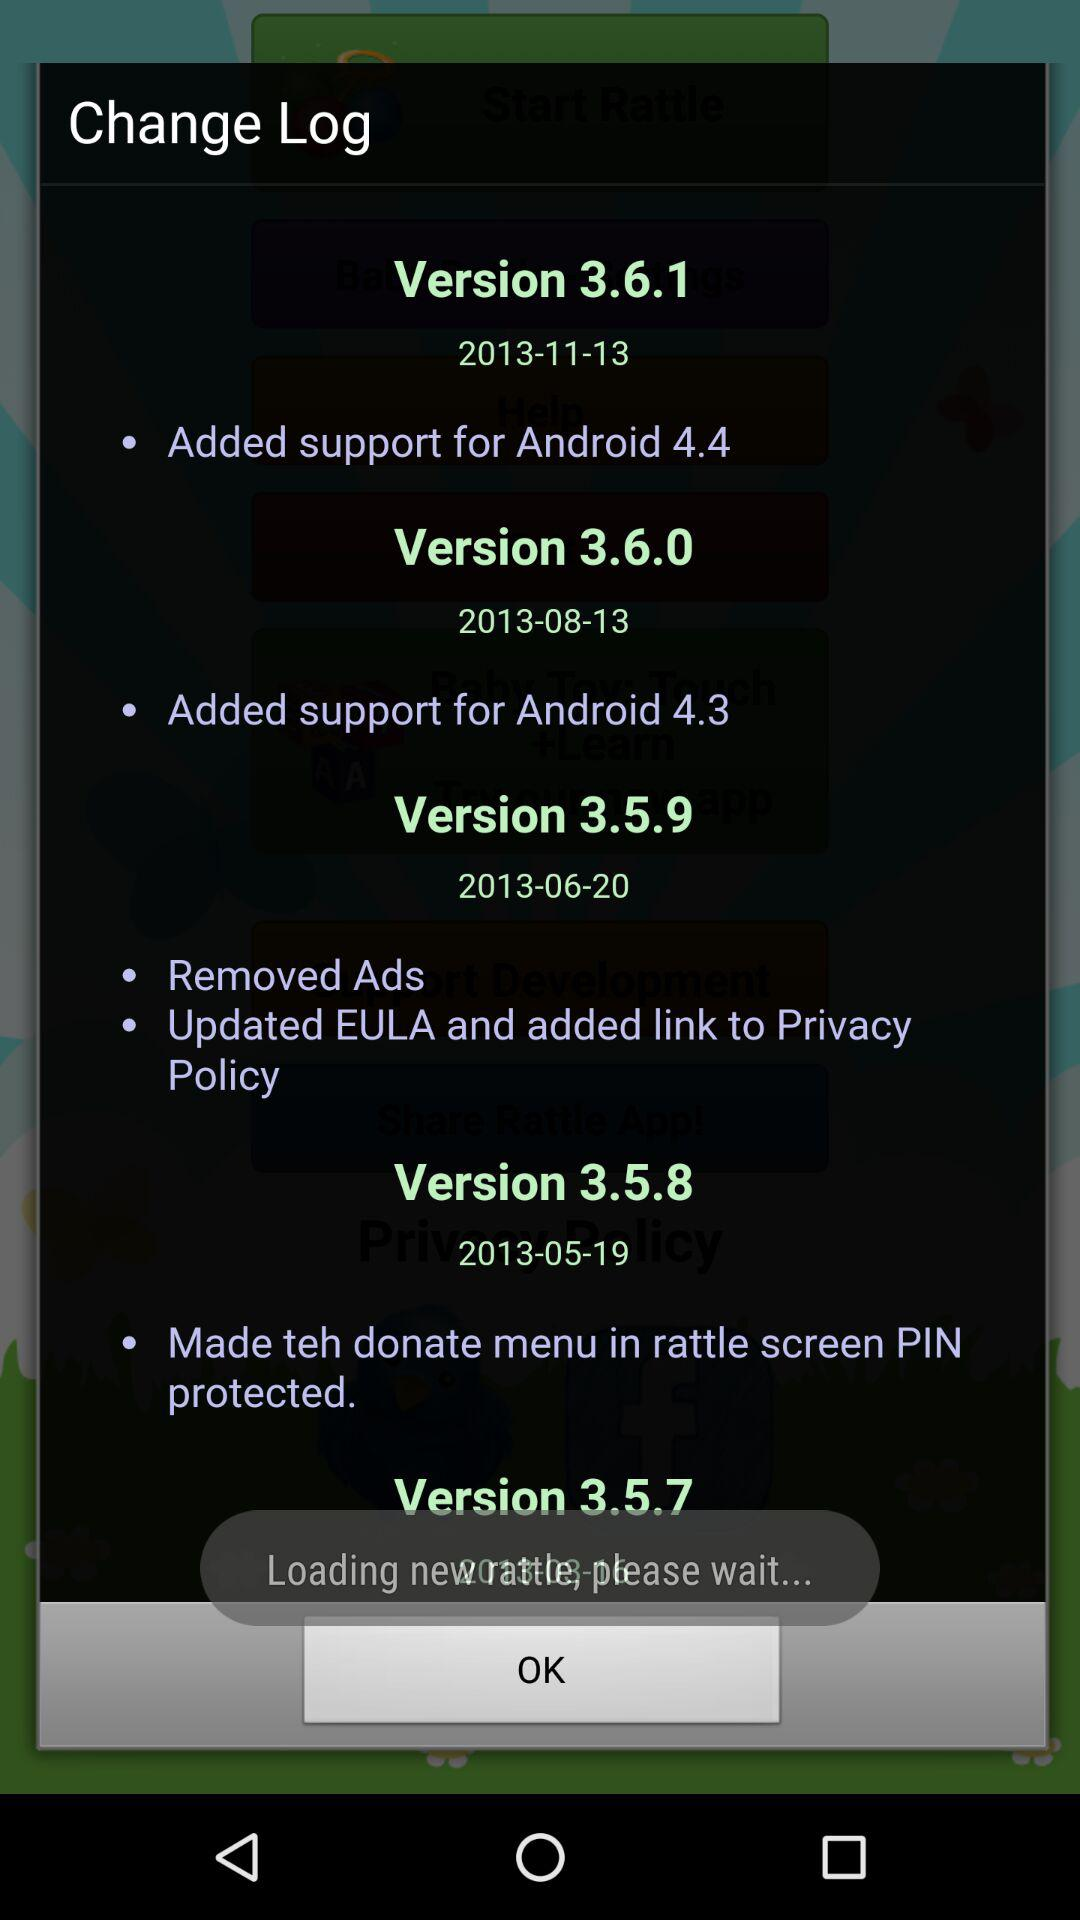What is the release date of version 3.6.0? The release date is August 13, 2013. 